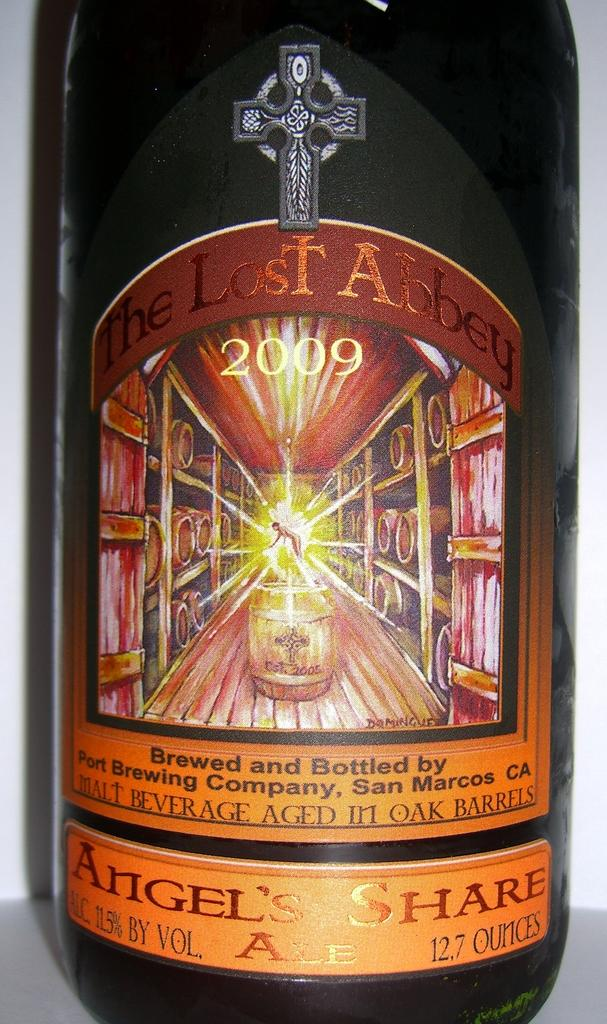<image>
Write a terse but informative summary of the picture. Bottle of The Lost Abbey 2009 brewed and bottled by Port Brewing Company, San Marcos CA 